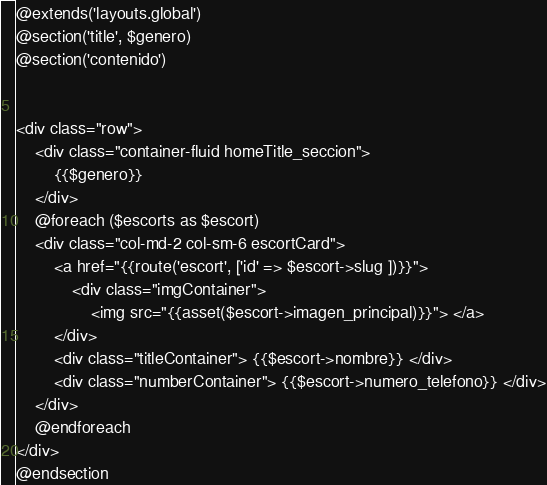Convert code to text. <code><loc_0><loc_0><loc_500><loc_500><_PHP_>@extends('layouts.global') 
@section('title', $genero) 
@section('contenido')


<div class="row">
    <div class="container-fluid homeTitle_seccion">
        {{$genero}}
    </div>
    @foreach ($escorts as $escort)
    <div class="col-md-2 col-sm-6 escortCard">
        <a href="{{route('escort', ['id' => $escort->slug ])}}">
            <div class="imgContainer">
                <img src="{{asset($escort->imagen_principal)}}"> </a>
        </div>
        <div class="titleContainer"> {{$escort->nombre}} </div>
        <div class="numberContainer"> {{$escort->numero_telefono}} </div>
    </div>
    @endforeach
</div>
@endsection
</code> 